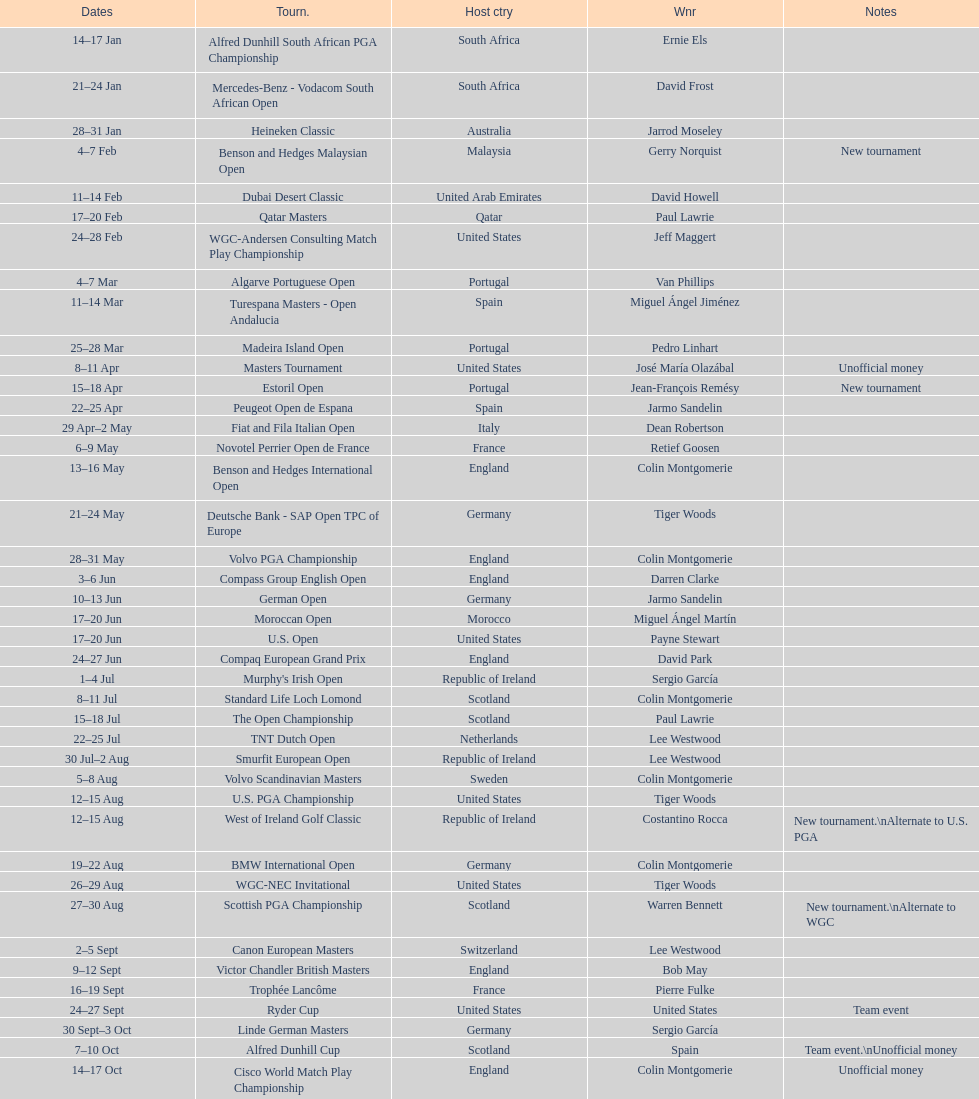How many tournaments began before aug 15th 31. 